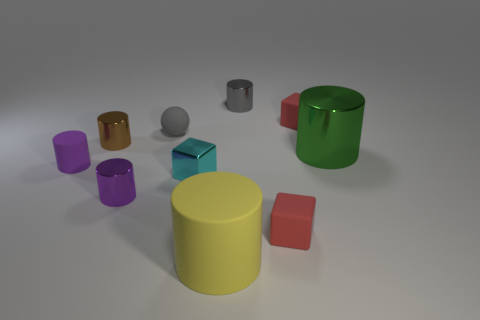Are there more metal blocks that are to the left of the yellow cylinder than red things behind the green shiny object?
Provide a succinct answer. No. What color is the tiny metal object that is behind the tiny red rubber block behind the small gray rubber sphere?
Provide a short and direct response. Gray. Is there a ball of the same color as the shiny cube?
Your response must be concise. No. How big is the matte block in front of the gray thing in front of the small red object behind the tiny sphere?
Offer a very short reply. Small. The small cyan object is what shape?
Keep it short and to the point. Cube. There is a cylinder that is the same color as the tiny rubber sphere; what is its size?
Your answer should be very brief. Small. There is a large thing that is on the right side of the yellow matte thing; how many tiny rubber cubes are behind it?
Offer a terse response. 1. What number of other things are made of the same material as the big green object?
Provide a succinct answer. 4. Do the big thing that is right of the gray cylinder and the purple cylinder that is behind the cyan cube have the same material?
Offer a very short reply. No. Is there anything else that has the same shape as the cyan metal thing?
Give a very brief answer. Yes. 